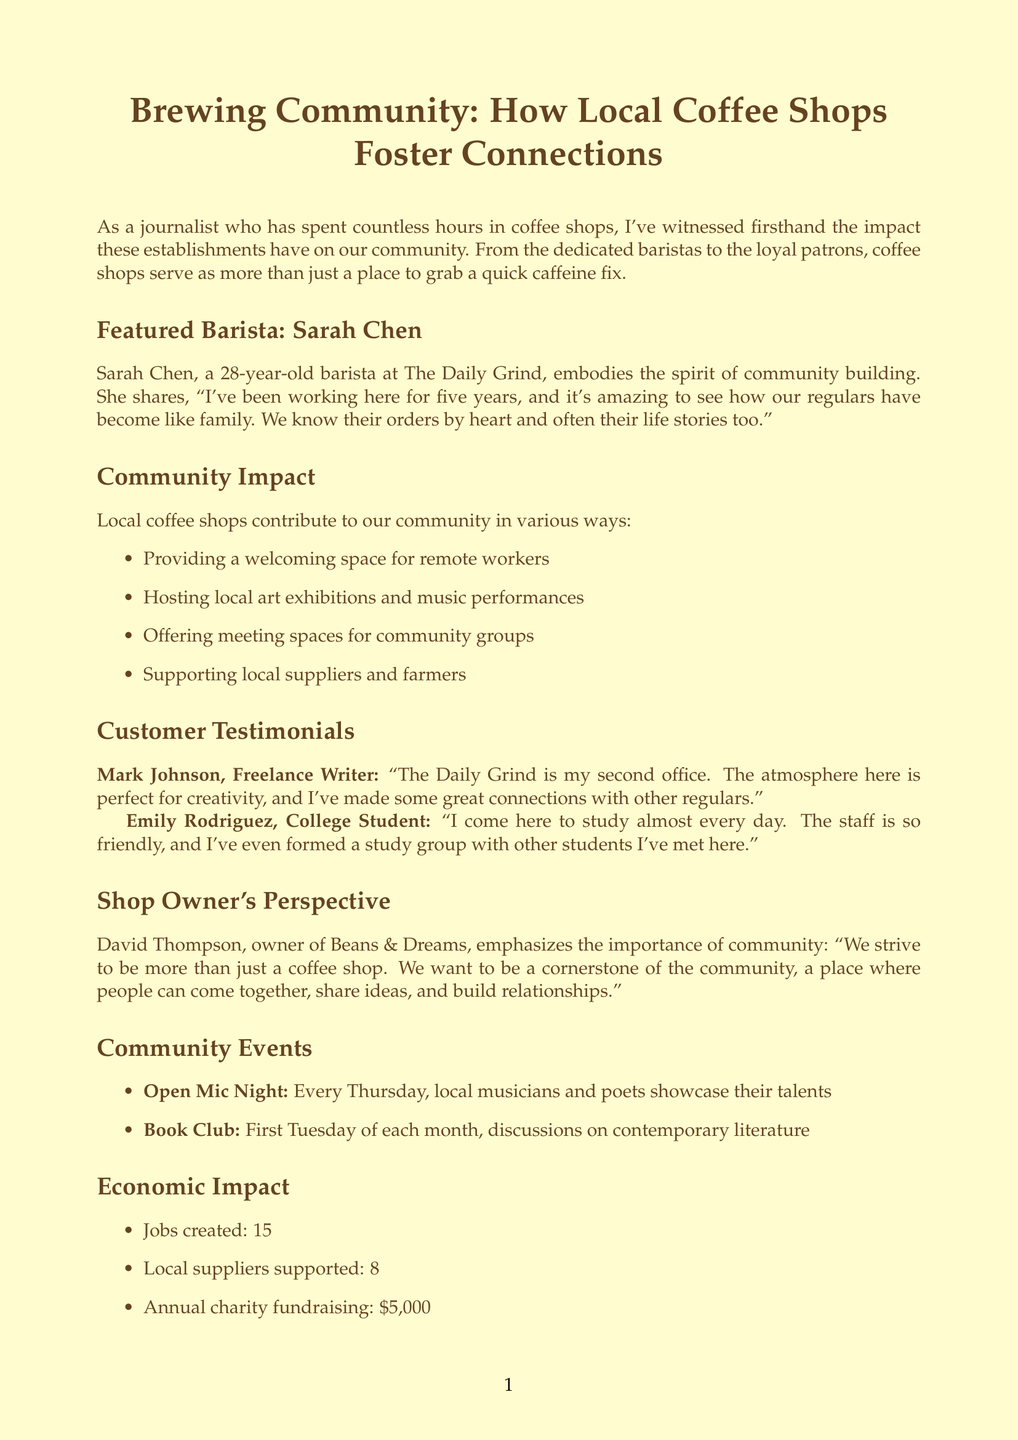What is the title of the article? The title of the article is mentioned at the beginning of the document.
Answer: Brewing Community: How Local Coffee Shops Foster Connections Who is the featured barista? The featured barista is listed in the document under the section about the barista.
Answer: Sarah Chen What is the age of Sarah Chen? Sarah Chen's age is stated in her introduction in the document.
Answer: 28 How many jobs have coffee shops created? The number of jobs created is detailed in the economic impact section of the document.
Answer: 15 What community event happens every Thursday? The specific event is mentioned under the community events section of the document.
Answer: Open Mic Night What type of food places do The Daily Grind and Beans & Dreams strive to be? The shop owner's perspective provides insight into the mission of these coffee shops.
Answer: Cornerstone of the community How many local suppliers does the coffee shop support? This information is found in the economic impact section of the document.
Answer: 8 What is the annual charity fundraising amount? The annual charity fundraising figure is listed in the economic impact section of the document.
Answer: $5,000 What does Emily Rodriguez use the coffee shop for? Emily Rodriguez’s quote reveals her purpose for visiting the coffee shop.
Answer: Study 